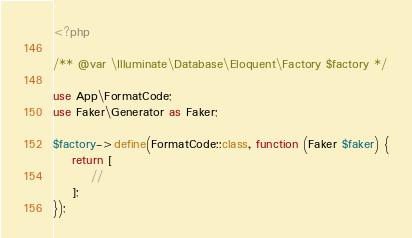Convert code to text. <code><loc_0><loc_0><loc_500><loc_500><_PHP_><?php

/** @var \Illuminate\Database\Eloquent\Factory $factory */

use App\FormatCode;
use Faker\Generator as Faker;

$factory->define(FormatCode::class, function (Faker $faker) {
    return [
        //
    ];
});
</code> 